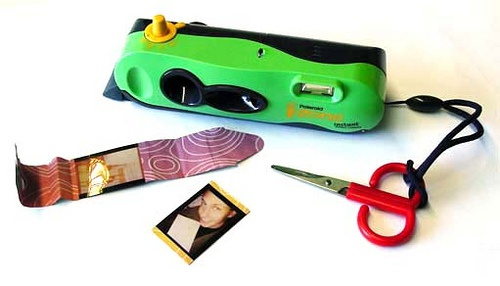Describe the objects in this image and their specific colors. I can see scissors in ivory, red, brown, white, and tan tones in this image. 